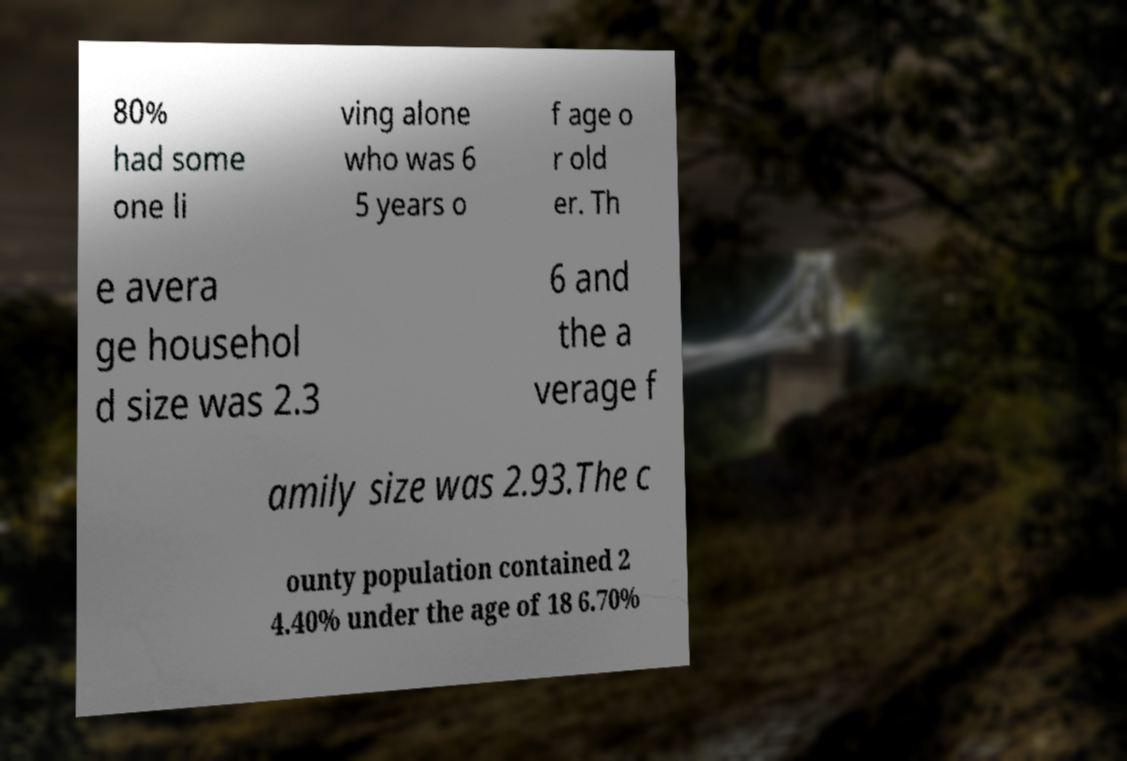Could you extract and type out the text from this image? 80% had some one li ving alone who was 6 5 years o f age o r old er. Th e avera ge househol d size was 2.3 6 and the a verage f amily size was 2.93.The c ounty population contained 2 4.40% under the age of 18 6.70% 